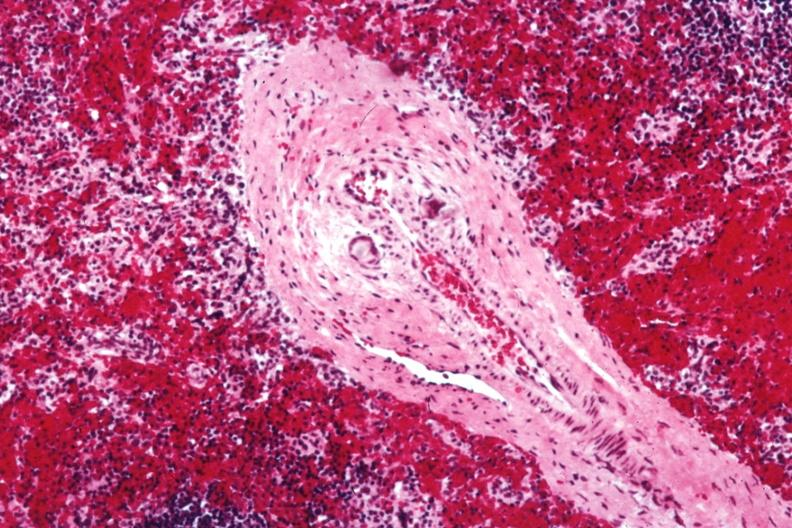s not too spectacular discs containing crystalline material postoperative cardiac surgery thought to be silicon?
Answer the question using a single word or phrase. No 